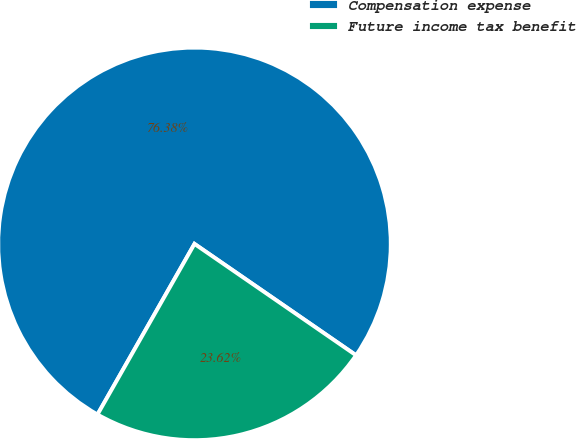Convert chart. <chart><loc_0><loc_0><loc_500><loc_500><pie_chart><fcel>Compensation expense<fcel>Future income tax benefit<nl><fcel>76.38%<fcel>23.62%<nl></chart> 